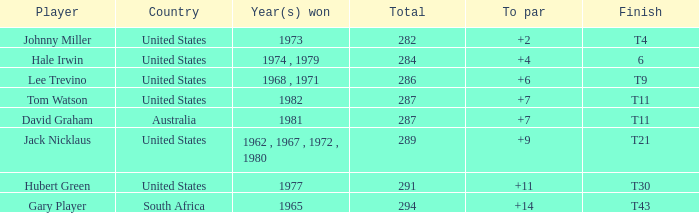What is the equivalent of a t11 finish, for david graham? 7.0. 